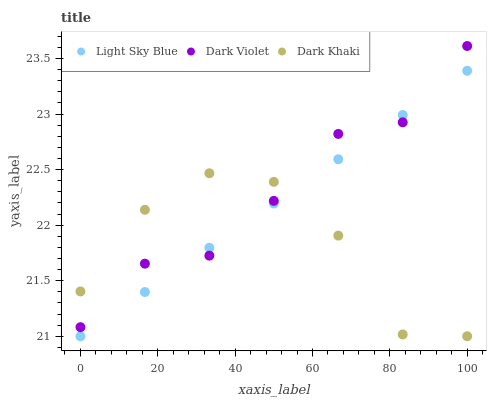Does Dark Khaki have the minimum area under the curve?
Answer yes or no. Yes. Does Dark Violet have the maximum area under the curve?
Answer yes or no. Yes. Does Light Sky Blue have the minimum area under the curve?
Answer yes or no. No. Does Light Sky Blue have the maximum area under the curve?
Answer yes or no. No. Is Light Sky Blue the smoothest?
Answer yes or no. Yes. Is Dark Khaki the roughest?
Answer yes or no. Yes. Is Dark Violet the smoothest?
Answer yes or no. No. Is Dark Violet the roughest?
Answer yes or no. No. Does Dark Khaki have the lowest value?
Answer yes or no. Yes. Does Dark Violet have the lowest value?
Answer yes or no. No. Does Dark Violet have the highest value?
Answer yes or no. Yes. Does Light Sky Blue have the highest value?
Answer yes or no. No. Does Dark Khaki intersect Light Sky Blue?
Answer yes or no. Yes. Is Dark Khaki less than Light Sky Blue?
Answer yes or no. No. Is Dark Khaki greater than Light Sky Blue?
Answer yes or no. No. 